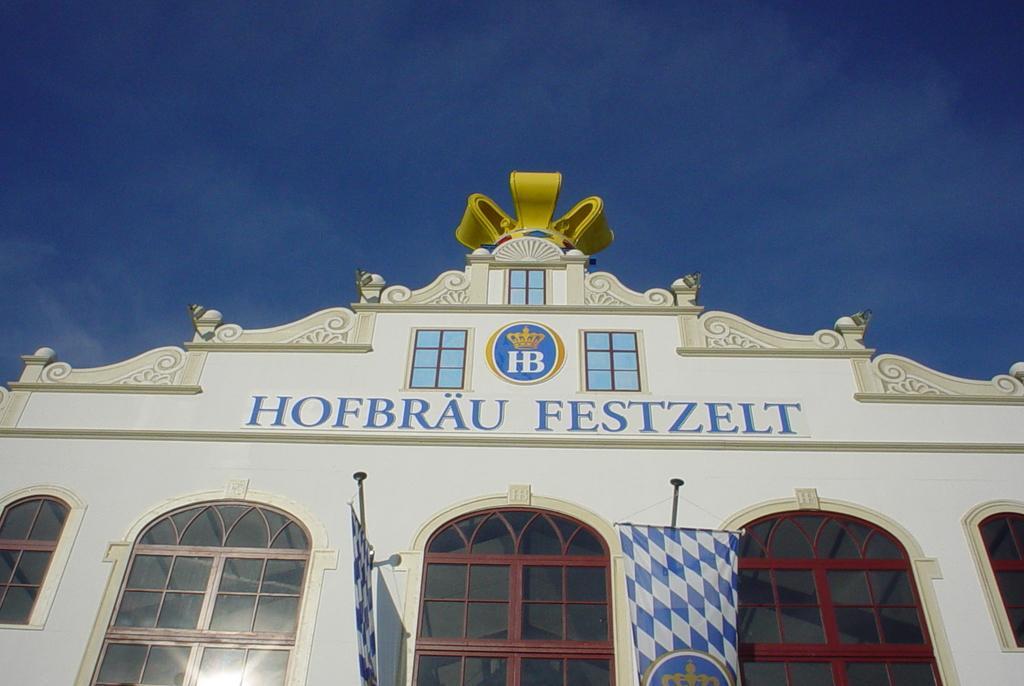Please provide a concise description of this image. In this image I can see a building in white color. I can also see two banners in blue and white color. Background I can see sky in blue color. 